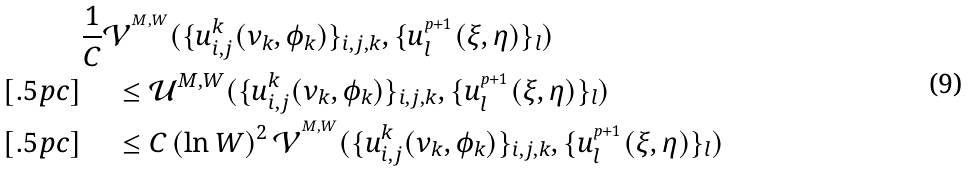Convert formula to latex. <formula><loc_0><loc_0><loc_500><loc_500>& \frac { 1 } { C } \mathcal { V } ^ { ^ { M , W } } ( \{ u _ { i , j } ^ { k } ( \nu _ { k } , \phi _ { k } ) \} _ { i , j , k } , \{ u _ { l } ^ { _ { ^ { p + 1 } } } ( \xi , \eta ) \} _ { l } ) \\ [ . 5 p c ] & \quad \, \leq \mathcal { U } ^ { M , W } ( \{ u _ { i , j } ^ { k } ( \nu _ { k } , \phi _ { k } ) \} _ { i , j , k } , \{ u _ { l } ^ { _ { ^ { p + 1 } } } ( \xi , \eta ) \} _ { l } ) \\ [ . 5 p c ] & \quad \, \leq C \, ( \ln W ) ^ { 2 } \, \mathcal { V } ^ { ^ { M , W } } ( \{ u _ { i , j } ^ { k } ( \nu _ { k } , \phi _ { k } ) \} _ { i , j , k } , \{ u _ { l } ^ { _ { ^ { p + 1 } } } ( \xi , \eta ) \} _ { l } )</formula> 